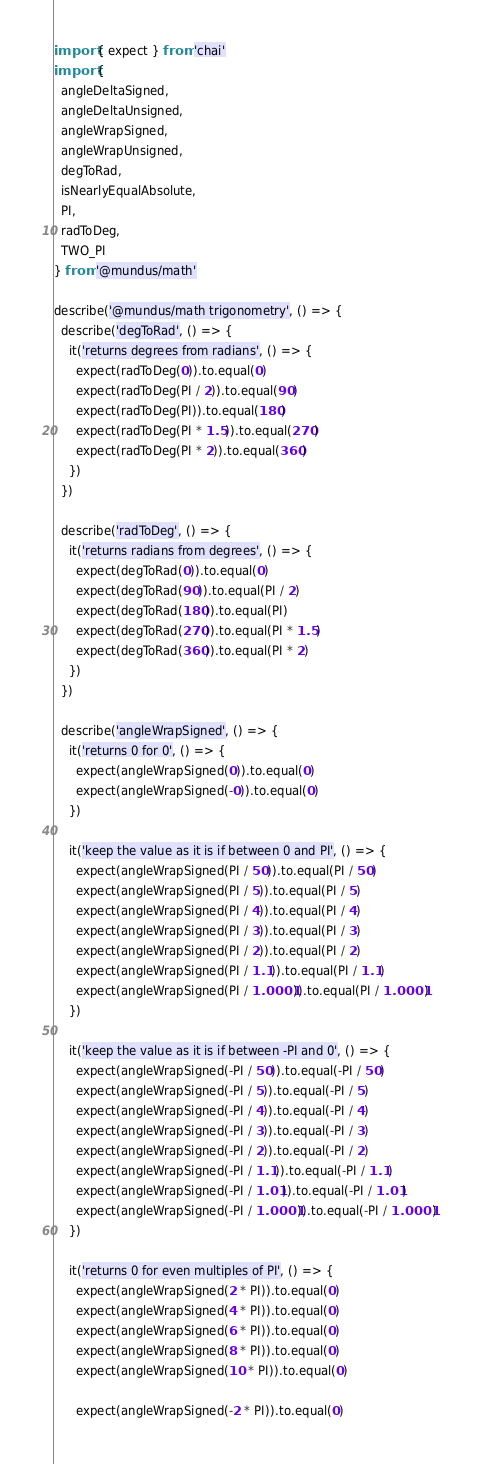<code> <loc_0><loc_0><loc_500><loc_500><_TypeScript_>import { expect } from 'chai'
import {
  angleDeltaSigned,
  angleDeltaUnsigned,
  angleWrapSigned,
  angleWrapUnsigned,
  degToRad,
  isNearlyEqualAbsolute,
  PI,
  radToDeg,
  TWO_PI
} from '@mundus/math'

describe('@mundus/math trigonometry', () => {
  describe('degToRad', () => {
    it('returns degrees from radians', () => {
      expect(radToDeg(0)).to.equal(0)
      expect(radToDeg(PI / 2)).to.equal(90)
      expect(radToDeg(PI)).to.equal(180)
      expect(radToDeg(PI * 1.5)).to.equal(270)
      expect(radToDeg(PI * 2)).to.equal(360)
    })
  })

  describe('radToDeg', () => {
    it('returns radians from degrees', () => {
      expect(degToRad(0)).to.equal(0)
      expect(degToRad(90)).to.equal(PI / 2)
      expect(degToRad(180)).to.equal(PI)
      expect(degToRad(270)).to.equal(PI * 1.5)
      expect(degToRad(360)).to.equal(PI * 2)
    })
  })

  describe('angleWrapSigned', () => {
    it('returns 0 for 0', () => {
      expect(angleWrapSigned(0)).to.equal(0)
      expect(angleWrapSigned(-0)).to.equal(0)
    })

    it('keep the value as it is if between 0 and PI', () => {
      expect(angleWrapSigned(PI / 50)).to.equal(PI / 50)
      expect(angleWrapSigned(PI / 5)).to.equal(PI / 5)
      expect(angleWrapSigned(PI / 4)).to.equal(PI / 4)
      expect(angleWrapSigned(PI / 3)).to.equal(PI / 3)
      expect(angleWrapSigned(PI / 2)).to.equal(PI / 2)
      expect(angleWrapSigned(PI / 1.1)).to.equal(PI / 1.1)
      expect(angleWrapSigned(PI / 1.0001)).to.equal(PI / 1.0001)
    })

    it('keep the value as it is if between -PI and 0', () => {
      expect(angleWrapSigned(-PI / 50)).to.equal(-PI / 50)
      expect(angleWrapSigned(-PI / 5)).to.equal(-PI / 5)
      expect(angleWrapSigned(-PI / 4)).to.equal(-PI / 4)
      expect(angleWrapSigned(-PI / 3)).to.equal(-PI / 3)
      expect(angleWrapSigned(-PI / 2)).to.equal(-PI / 2)
      expect(angleWrapSigned(-PI / 1.1)).to.equal(-PI / 1.1)
      expect(angleWrapSigned(-PI / 1.01)).to.equal(-PI / 1.01)
      expect(angleWrapSigned(-PI / 1.0001)).to.equal(-PI / 1.0001)
    })

    it('returns 0 for even multiples of PI', () => {
      expect(angleWrapSigned(2 * PI)).to.equal(0)
      expect(angleWrapSigned(4 * PI)).to.equal(0)
      expect(angleWrapSigned(6 * PI)).to.equal(0)
      expect(angleWrapSigned(8 * PI)).to.equal(0)
      expect(angleWrapSigned(10 * PI)).to.equal(0)

      expect(angleWrapSigned(-2 * PI)).to.equal(0)</code> 